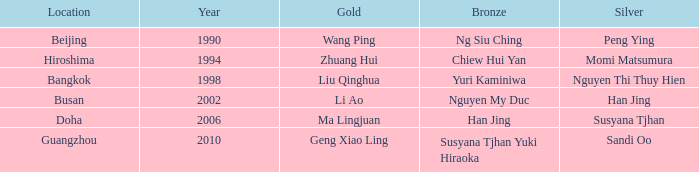What's the lowest Year with the Location of Bangkok? 1998.0. 